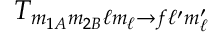Convert formula to latex. <formula><loc_0><loc_0><loc_500><loc_500>T _ { m _ { 1 A } m _ { 2 B } \ell m _ { \ell } \rightarrow f \ell ^ { \prime } m _ { \ell } ^ { \prime } }</formula> 